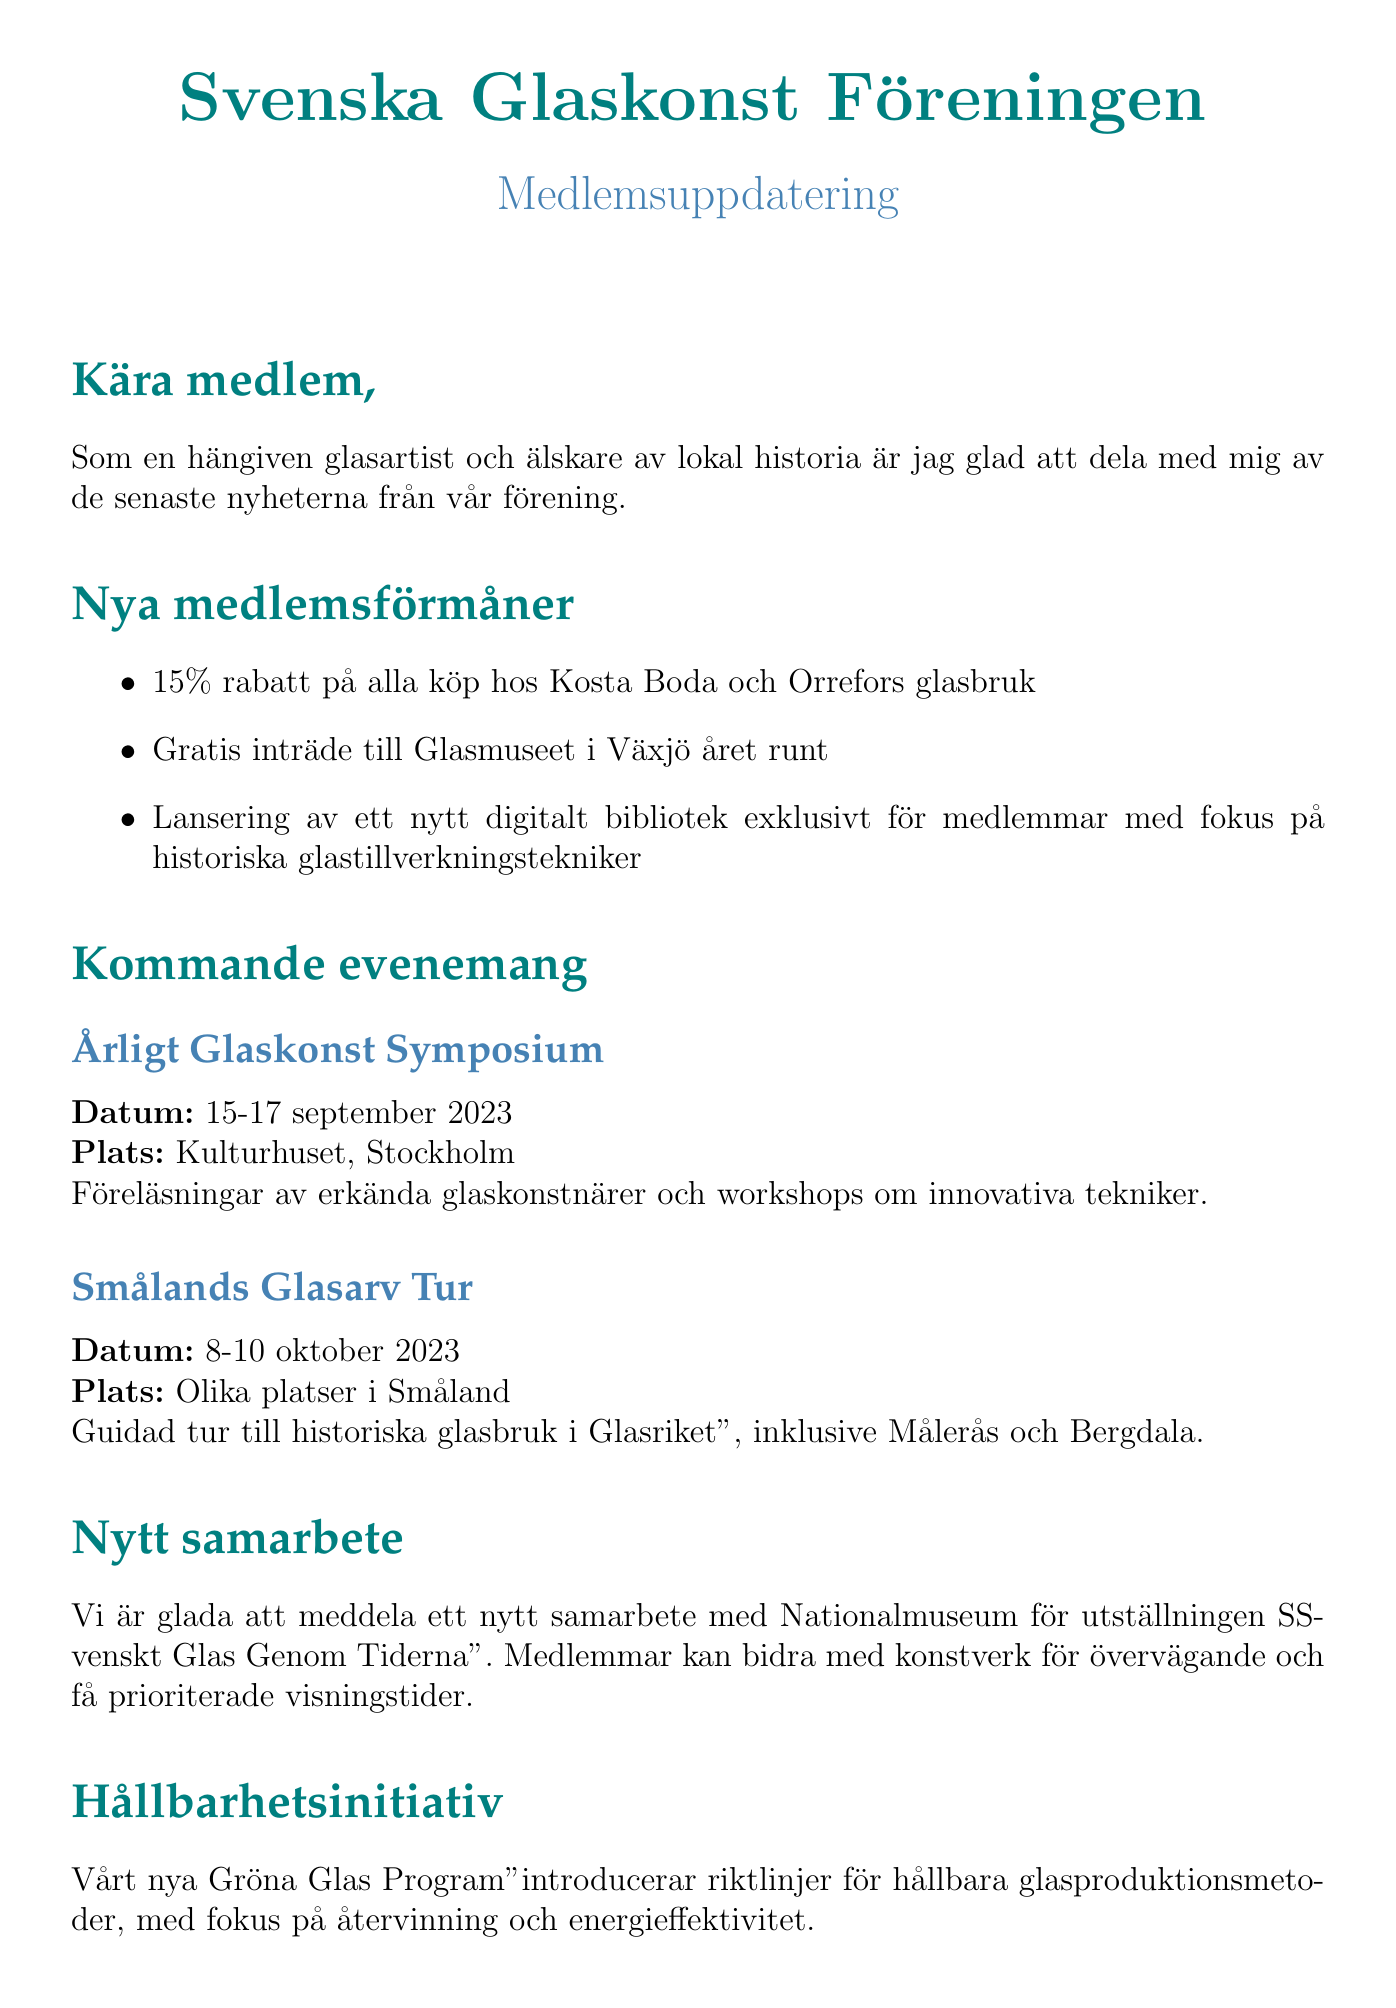what is the name of the association? The document indicates the name of the association as "Svenska Glaskonst Föreningen".
Answer: Svenska Glaskonst Föreningen what is the date of the Annual Glass Art Symposium? The specific date for the Annual Glass Art Symposium is given in the document.
Answer: September 15-17, 2023 what discount do members get at Kosta Boda and Orrefors? The document states the discount offered for purchases at Kosta Boda and Orrefors glassworks.
Answer: 15% off what is the focus topic of the local history feature in the next newsletter? The document mentions the specific topic of the local history feature.
Answer: Glassblowing in Värmland what is the membership renewal deadline? The document specifies the deadline for membership renewal.
Answer: December 31, 2023 what is the name of the new sustainability initiative? The document mentions the name of the newly introduced sustainability initiative.
Answer: Green Glass Program how can members benefit from the new exhibition at Nationalmuseum? The document describes how members can participate in the exhibition at Nationalmuseum.
Answer: Contribute artwork for consideration what is the early bird offer for membership renewal? The document details the early bird offer for renewing membership before a specific date.
Answer: 10% discount on membership fees 